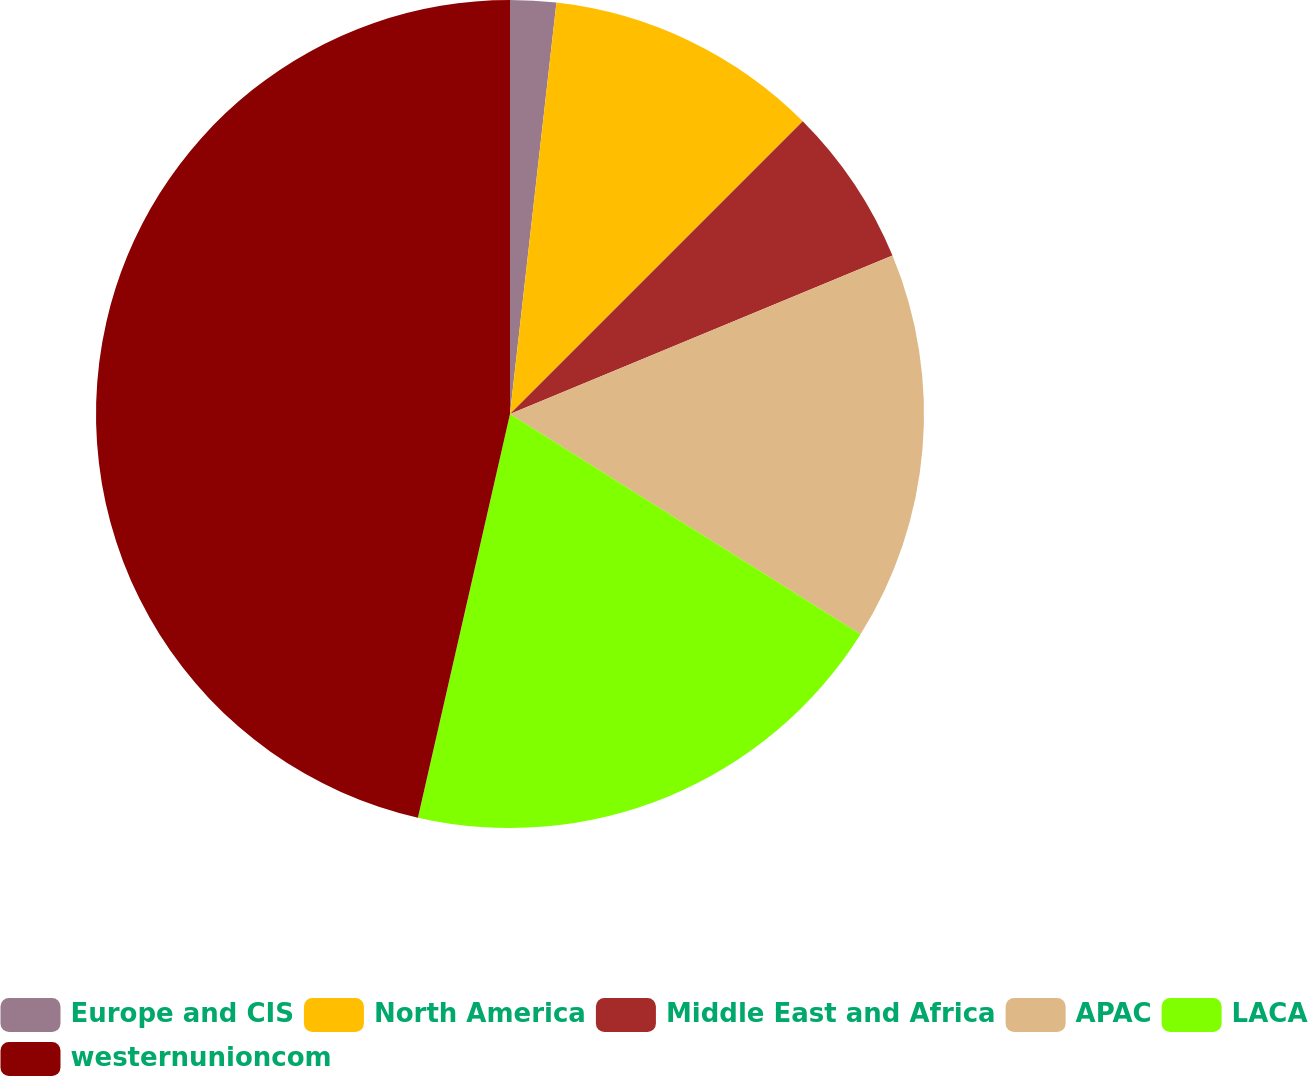Convert chart. <chart><loc_0><loc_0><loc_500><loc_500><pie_chart><fcel>Europe and CIS<fcel>North America<fcel>Middle East and Africa<fcel>APAC<fcel>LACA<fcel>westernunioncom<nl><fcel>1.79%<fcel>10.71%<fcel>6.25%<fcel>15.18%<fcel>19.64%<fcel>46.43%<nl></chart> 